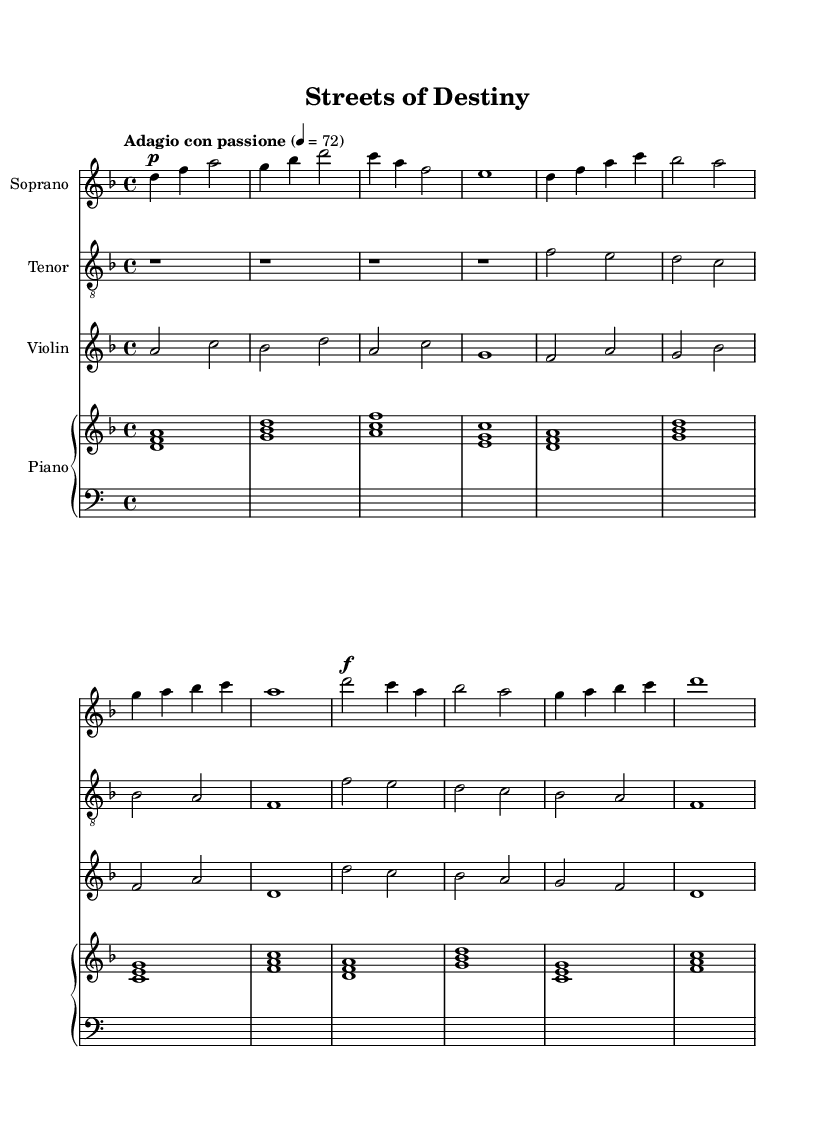What is the key signature of this music? The key signature is indicated at the beginning of the score, showing D minor, which has one flat.
Answer: D minor What is the time signature of this piece? The time signature is written as 4/4 at the beginning of the score, indicating that there are four beats in each measure.
Answer: 4/4 What is the tempo marking for this piece? The tempo marking shown at the start of the score is "Adagio con passione," which indicates a slow, passionate tempo.
Answer: Adagio con passione How many measures are in the soprano part? By counting the measures in the soprano line, there are a total of 9 measures present in the excerpt.
Answer: 9 What is the dynamic marking at the beginning of the chorus in the soprano part? The dynamic marking in the score indicates "f" (forte), meaning to sing loudly, at the beginning of the chorus.
Answer: f How many different instruments are featured in this opera? The score includes four different instruments: soprano, tenor, violin, and piano.
Answer: Four What is the lyrical theme expressed in the text? The lyrics reflect a struggle and hope, emphasizing the resilience of urban youth in a challenging environment based on phrases in the text.
Answer: Struggle and hope 